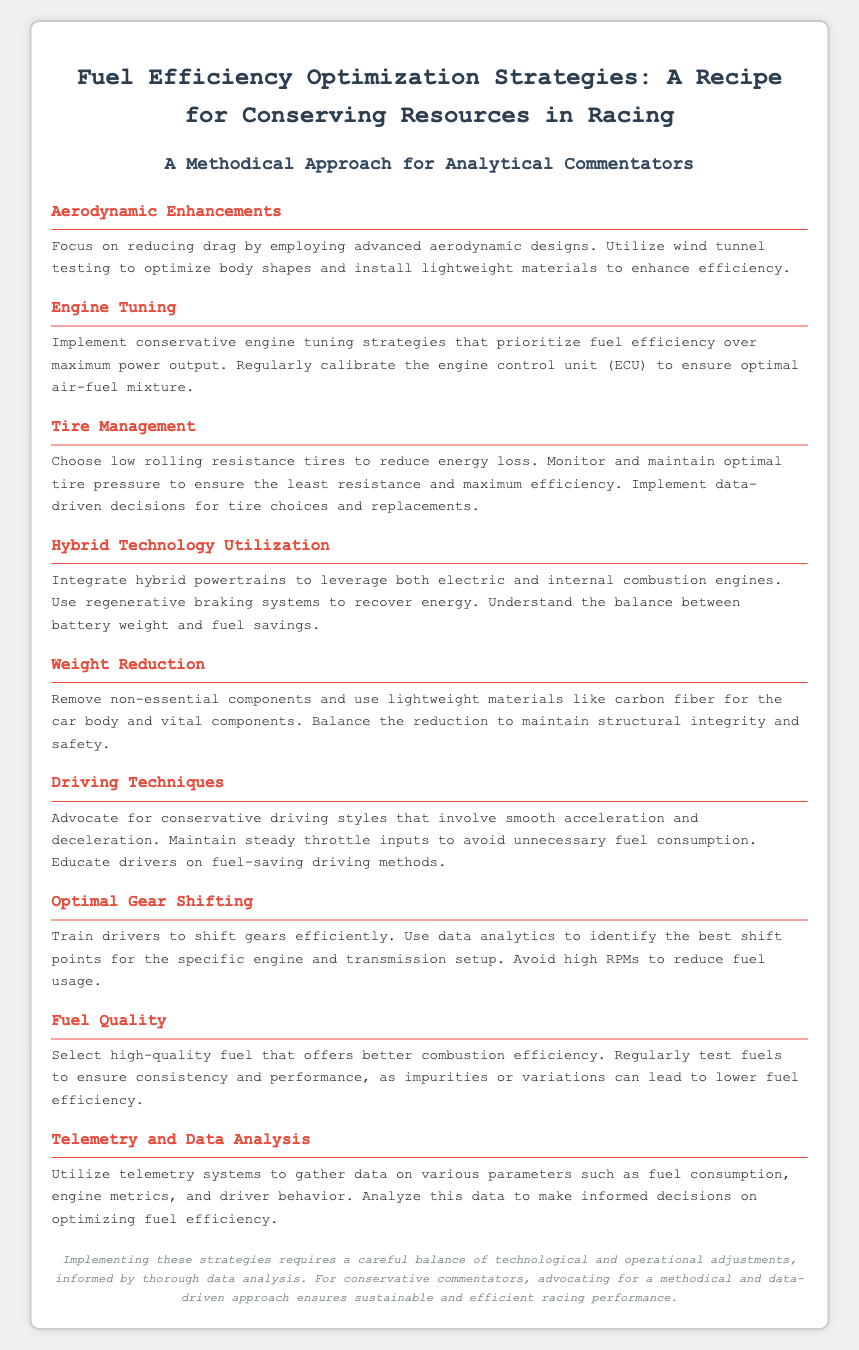What is the main title of the document? The main title is stated at the top of the document, summarizing the content's focus.
Answer: Fuel Efficiency Optimization Strategies: A Recipe for Conserving Resources in Racing What is one aerodynamic strategy mentioned? The document highlights advanced aerodynamic designs as a method to reduce drag.
Answer: Advanced aerodynamic designs What is a technique suggested for engine tuning? The document advises to prioritize fuel efficiency over maximum power output in tuning strategies.
Answer: Prioritize fuel efficiency What should be monitored to maintain tire efficiency? Maintaining optimal tire pressure is emphasized to reduce energy loss.
Answer: Optimal tire pressure What hybrid technology feature is mentioned? The document discusses the integration of regenerative braking systems to recover energy.
Answer: Regenerative braking systems What driving style is advocated for fuel efficiency? The recipe card suggests a smooth acceleration and deceleration technique for drivers.
Answer: Smooth acceleration and deceleration What is one benefit of utilizing telemetry systems? Telemetry systems are used to gather data on fuel consumption and enable informed decisions.
Answer: Gather data on fuel consumption What lightweight material is recommended for weight reduction? The document specifies carbon fiber as a suitable lightweight material for the car body.
Answer: Carbon fiber What is the suggested strategy for optimal gear shifting? The document advises training drivers to shift gears efficiently using data analytics.
Answer: Train drivers to shift gears efficiently 